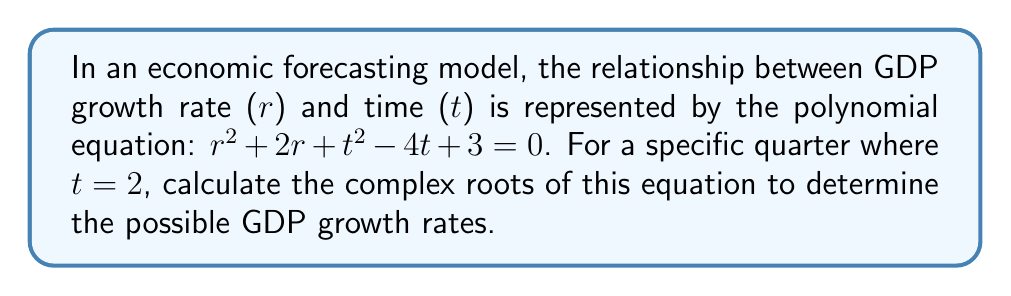Can you solve this math problem? 1) First, substitute $t = 2$ into the equation:
   $r^2 + 2r + 2^2 - 4(2) + 3 = 0$
   $r^2 + 2r + 4 - 8 + 3 = 0$
   $r^2 + 2r - 1 = 0$

2) This is now a quadratic equation in the standard form $ar^2 + br + c = 0$, where:
   $a = 1$, $b = 2$, and $c = -1$

3) We can use the quadratic formula: $r = \frac{-b \pm \sqrt{b^2 - 4ac}}{2a}$

4) Substituting the values:
   $r = \frac{-2 \pm \sqrt{2^2 - 4(1)(-1)}}{2(1)}$
   $r = \frac{-2 \pm \sqrt{4 + 4}}{2}$
   $r = \frac{-2 \pm \sqrt{8}}{2}$
   $r = \frac{-2 \pm 2\sqrt{2}}{2}$

5) Simplifying:
   $r = -1 \pm \sqrt{2}$

6) Therefore, the two roots are:
   $r_1 = -1 + \sqrt{2}$
   $r_2 = -1 - \sqrt{2}$
Answer: $r_1 = -1 + \sqrt{2}$, $r_2 = -1 - \sqrt{2}$ 